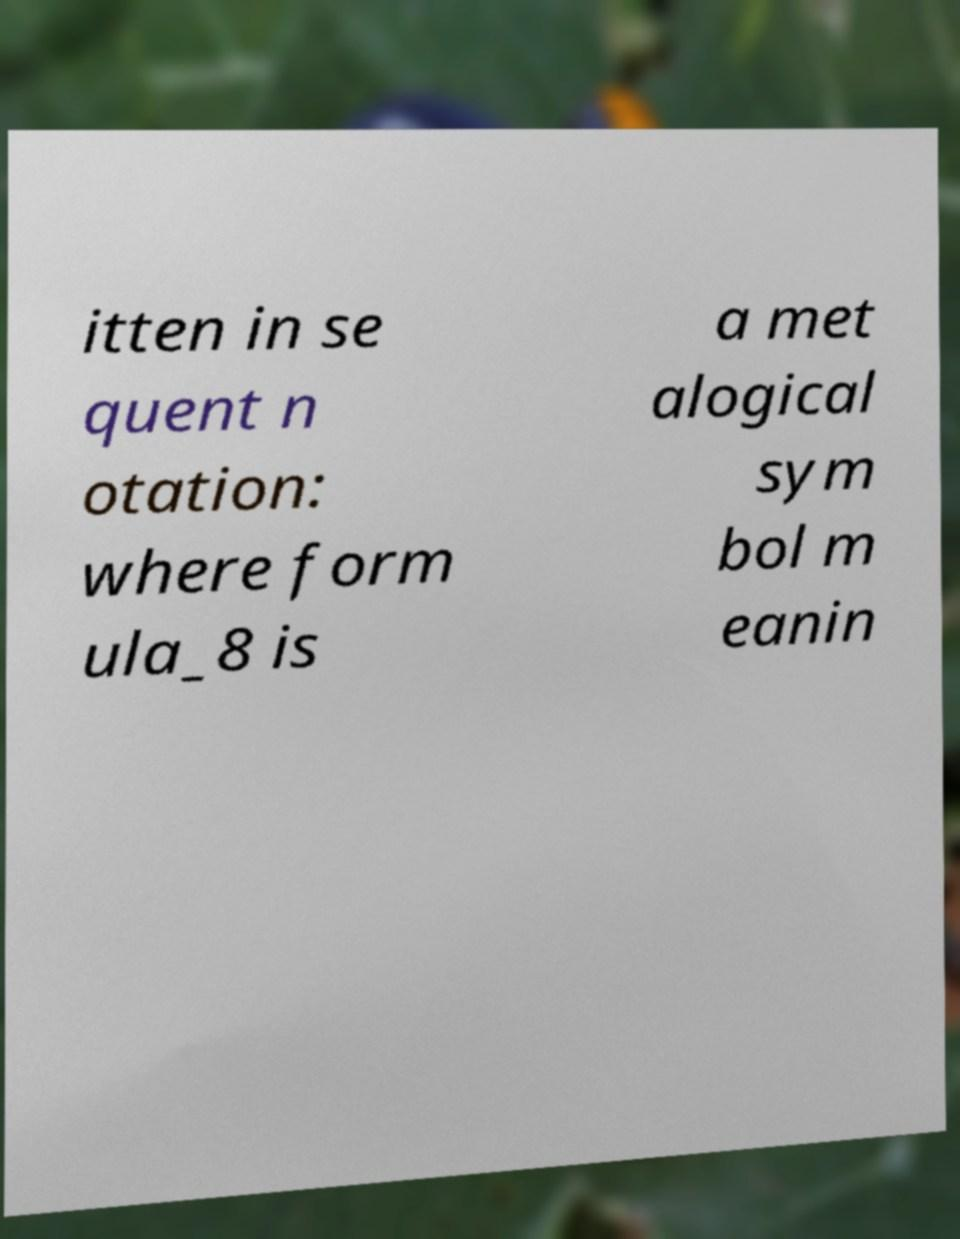There's text embedded in this image that I need extracted. Can you transcribe it verbatim? itten in se quent n otation: where form ula_8 is a met alogical sym bol m eanin 